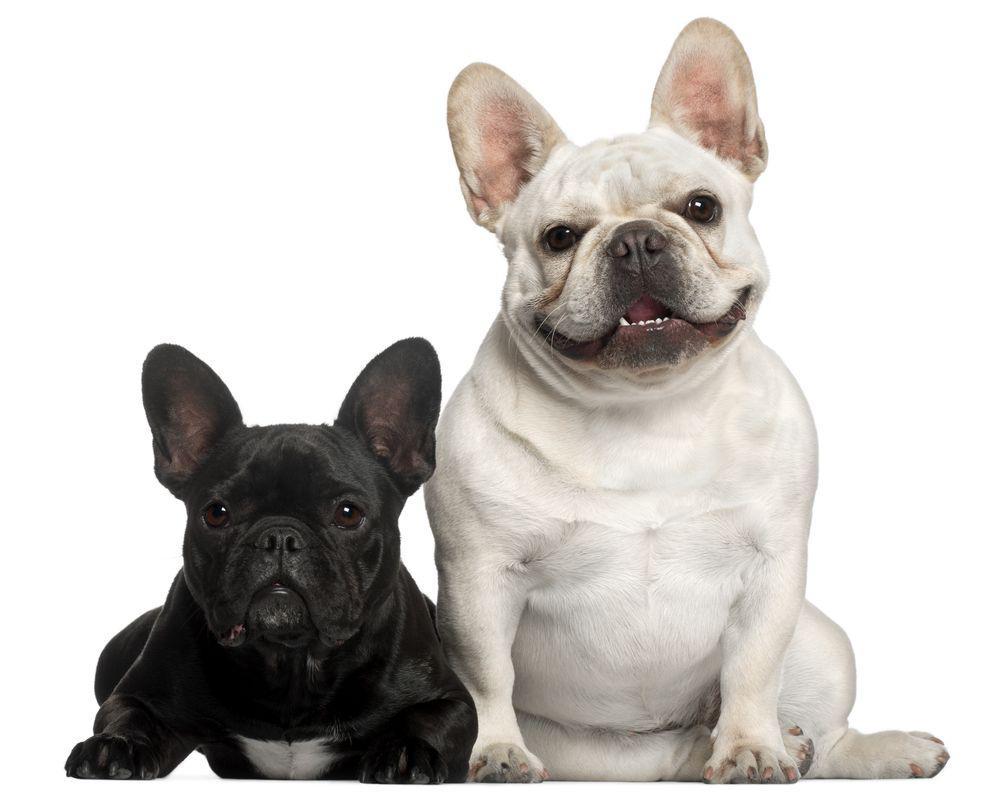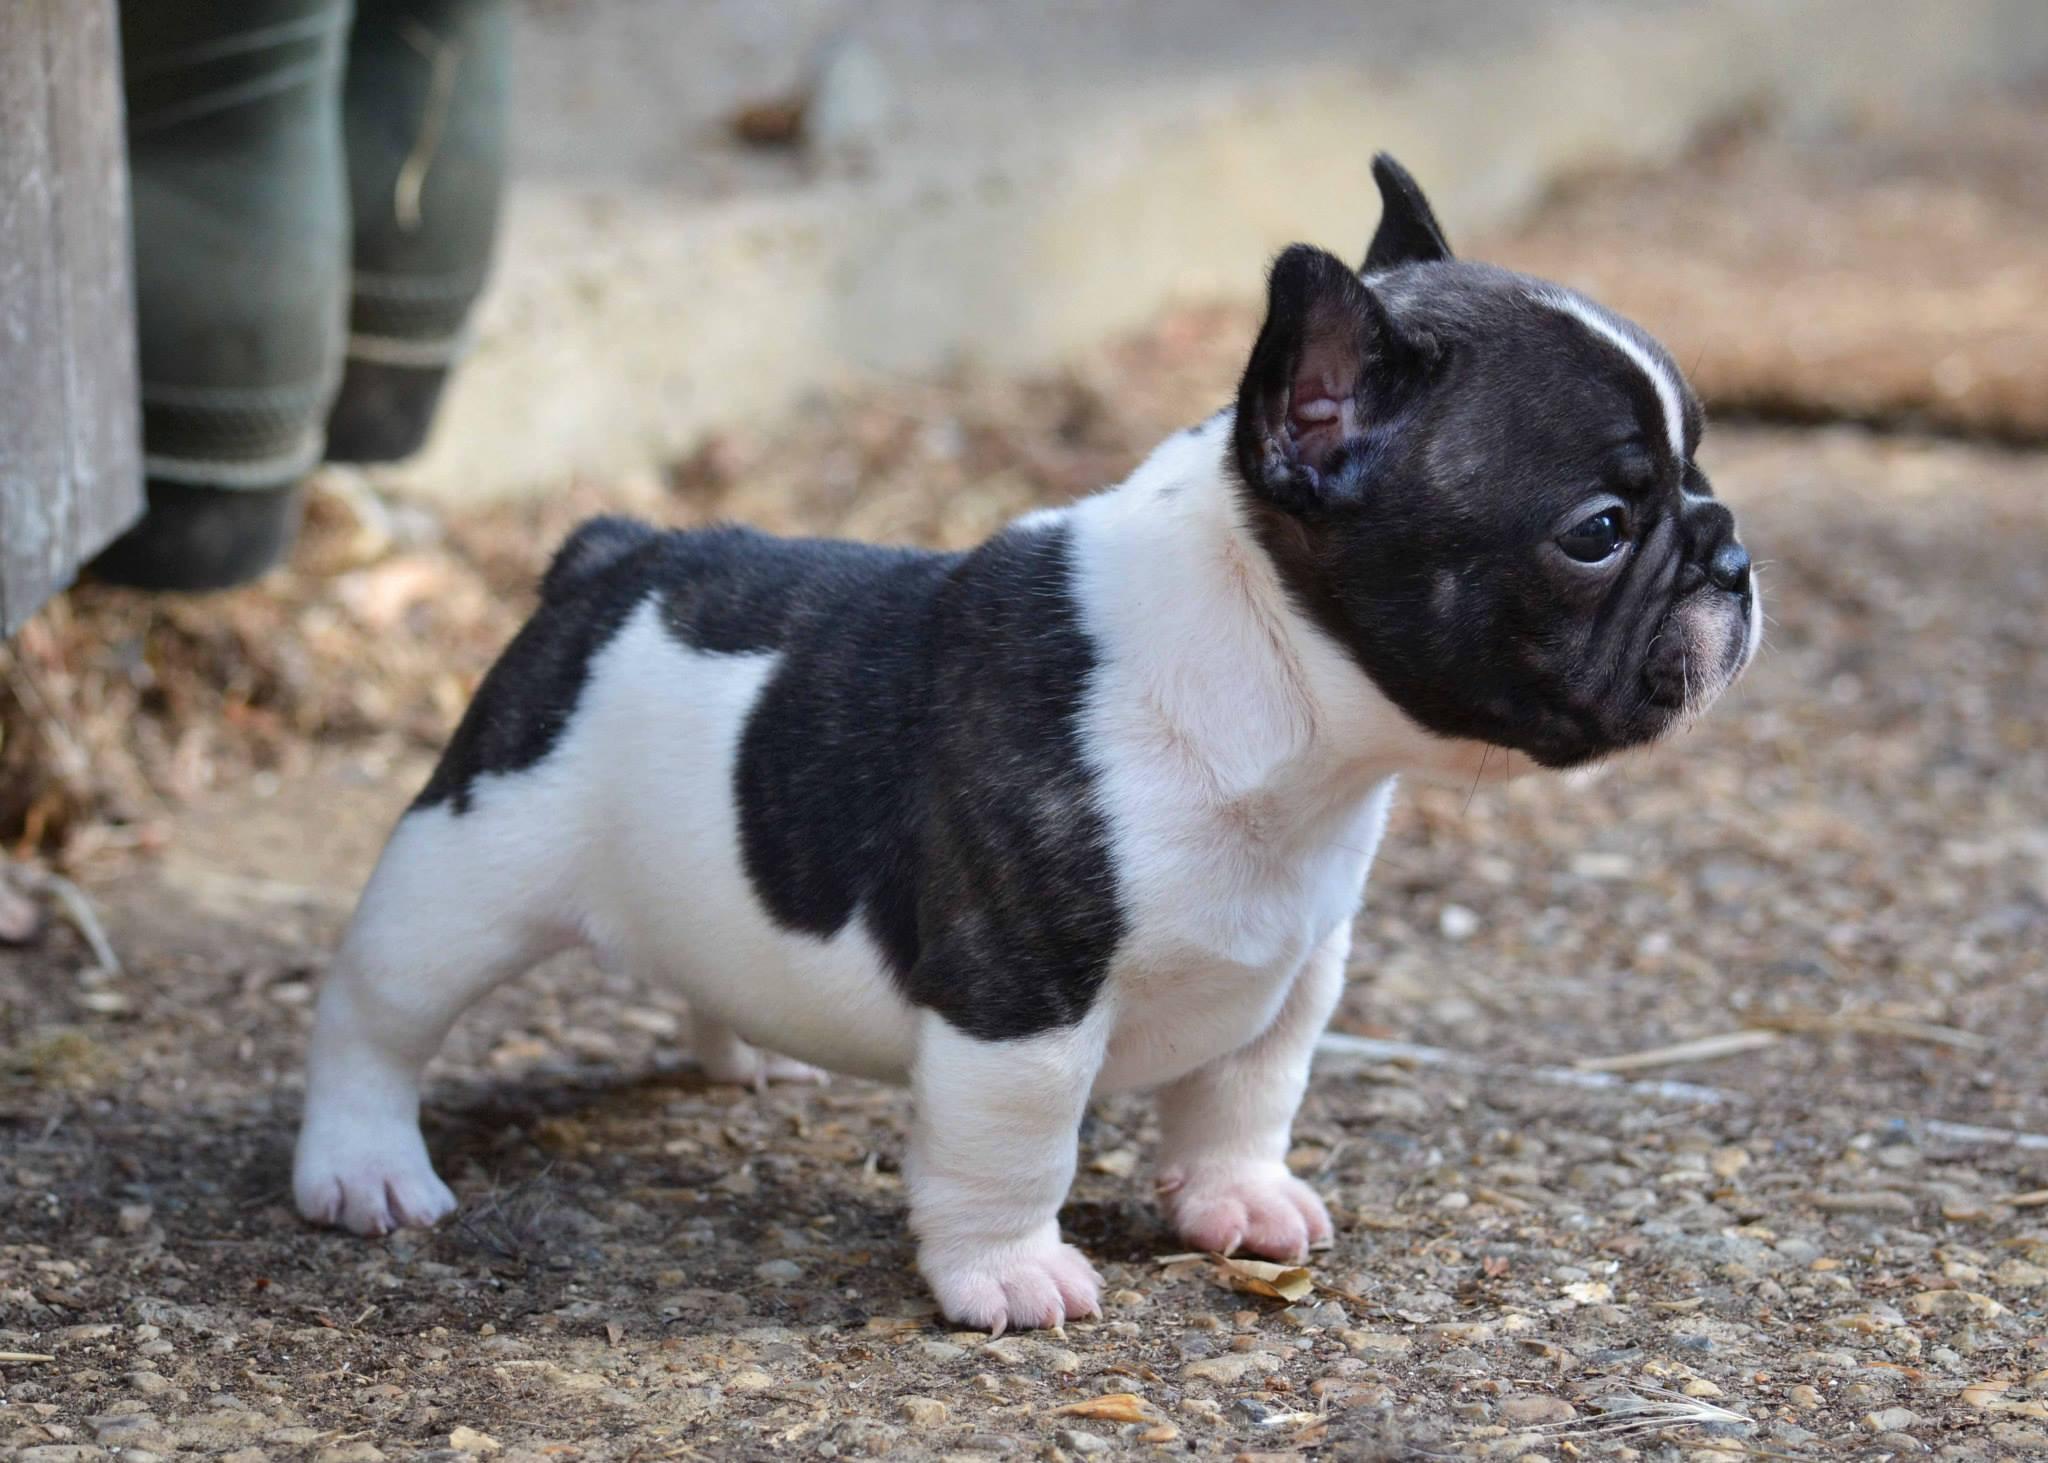The first image is the image on the left, the second image is the image on the right. Examine the images to the left and right. Is the description "The left image contains exactly two dogs that are seated next to each other." accurate? Answer yes or no. Yes. The first image is the image on the left, the second image is the image on the right. For the images shown, is this caption "An image contains exactly two side-by-side dogs, with a black one on the left and a white-bodied dog on the right." true? Answer yes or no. Yes. 